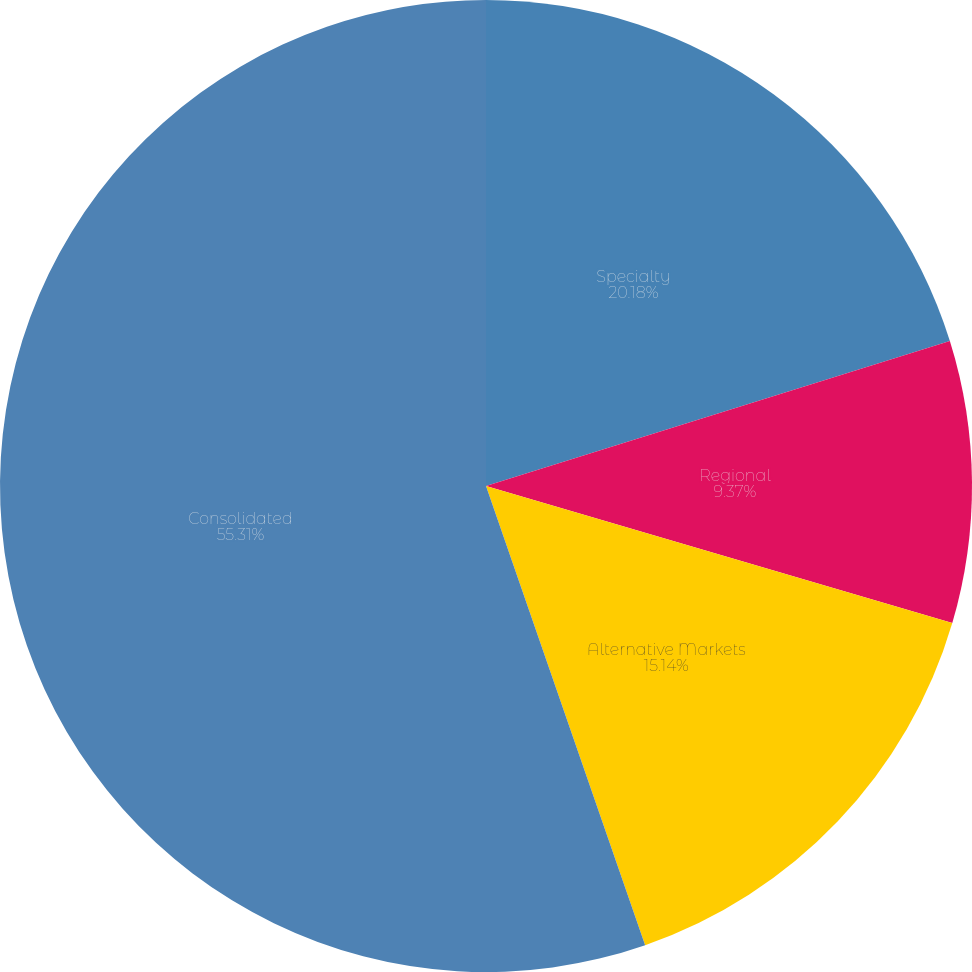Convert chart to OTSL. <chart><loc_0><loc_0><loc_500><loc_500><pie_chart><fcel>Specialty<fcel>Regional<fcel>Alternative Markets<fcel>Consolidated<nl><fcel>20.18%<fcel>9.37%<fcel>15.14%<fcel>55.31%<nl></chart> 